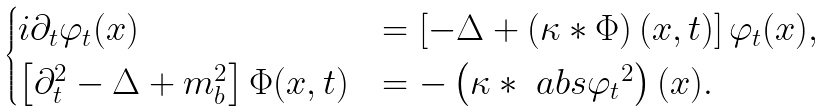<formula> <loc_0><loc_0><loc_500><loc_500>\begin{cases} i \partial _ { t } \varphi _ { t } ( x ) & = \left [ - \Delta + \left ( \kappa * \Phi \right ) ( x , t ) \right ] \varphi _ { t } ( x ) , \\ \left [ \partial _ { t } ^ { 2 } - \Delta + m _ { b } ^ { 2 } \right ] \Phi ( x , t ) & = - \left ( \kappa * \ a b s { \varphi _ { t } } ^ { 2 } \right ) ( x ) . \end{cases}</formula> 